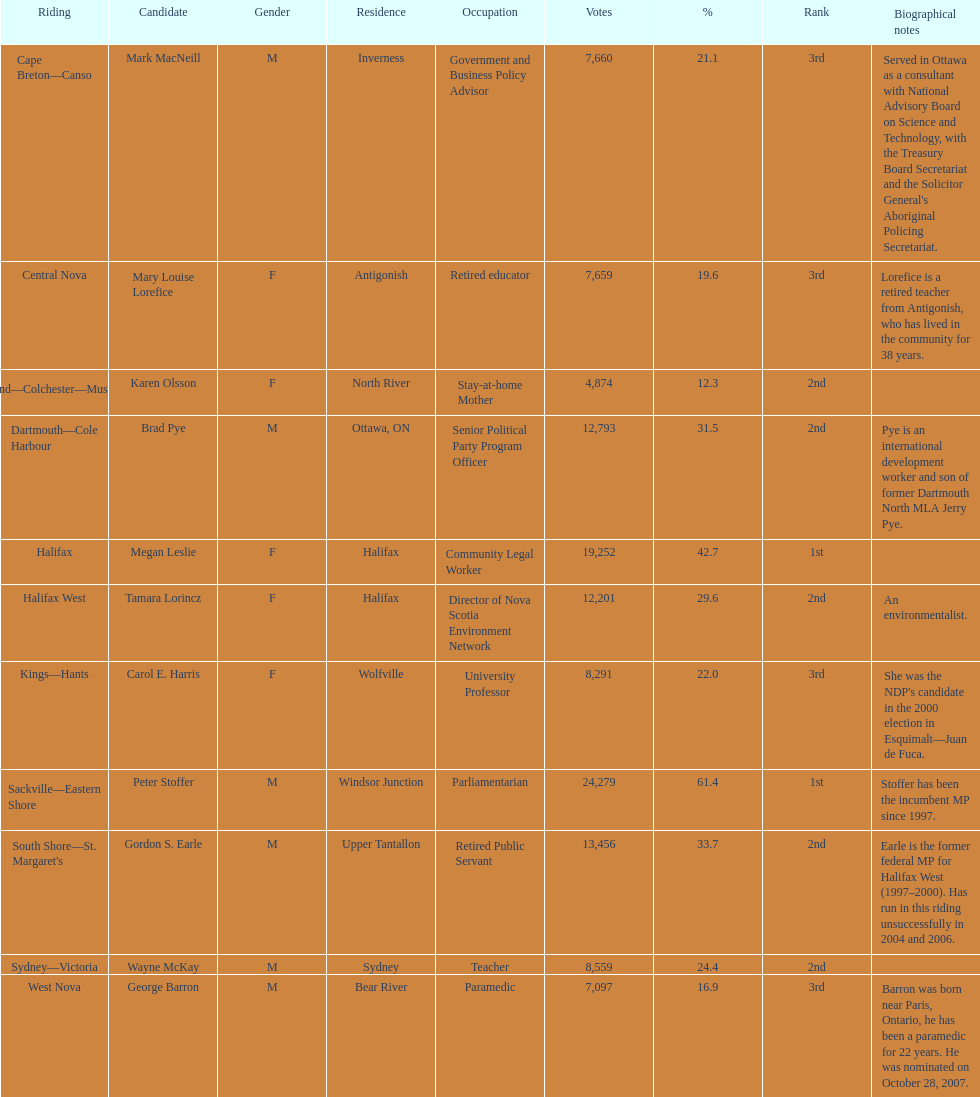How many participants were from halifax? 2. 